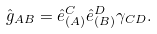<formula> <loc_0><loc_0><loc_500><loc_500>\hat { g } _ { A B } = \hat { e } _ { ( A ) } ^ { C } \hat { e } _ { ( B ) } ^ { D } \gamma _ { C D } .</formula> 